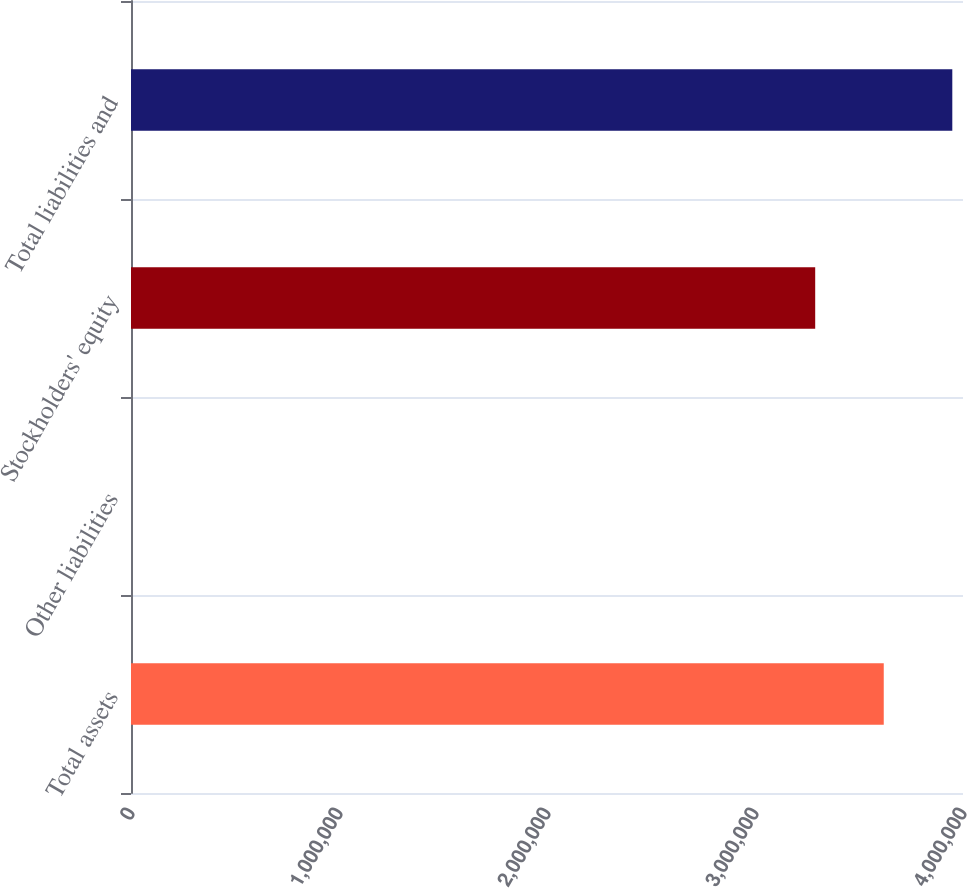<chart> <loc_0><loc_0><loc_500><loc_500><bar_chart><fcel>Total assets<fcel>Other liabilities<fcel>Stockholders' equity<fcel>Total liabilities and<nl><fcel>3.619e+06<fcel>12<fcel>3.28944e+06<fcel>3.94856e+06<nl></chart> 